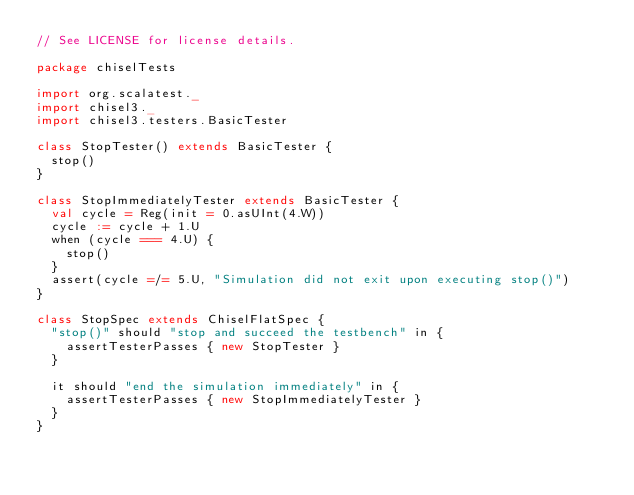<code> <loc_0><loc_0><loc_500><loc_500><_Scala_>// See LICENSE for license details.

package chiselTests

import org.scalatest._
import chisel3._
import chisel3.testers.BasicTester

class StopTester() extends BasicTester {
  stop()
}

class StopImmediatelyTester extends BasicTester {
  val cycle = Reg(init = 0.asUInt(4.W))
  cycle := cycle + 1.U
  when (cycle === 4.U) {
    stop()
  }
  assert(cycle =/= 5.U, "Simulation did not exit upon executing stop()")
}

class StopSpec extends ChiselFlatSpec {
  "stop()" should "stop and succeed the testbench" in {
    assertTesterPasses { new StopTester }
  }

  it should "end the simulation immediately" in {
    assertTesterPasses { new StopImmediatelyTester }
  }
}
</code> 